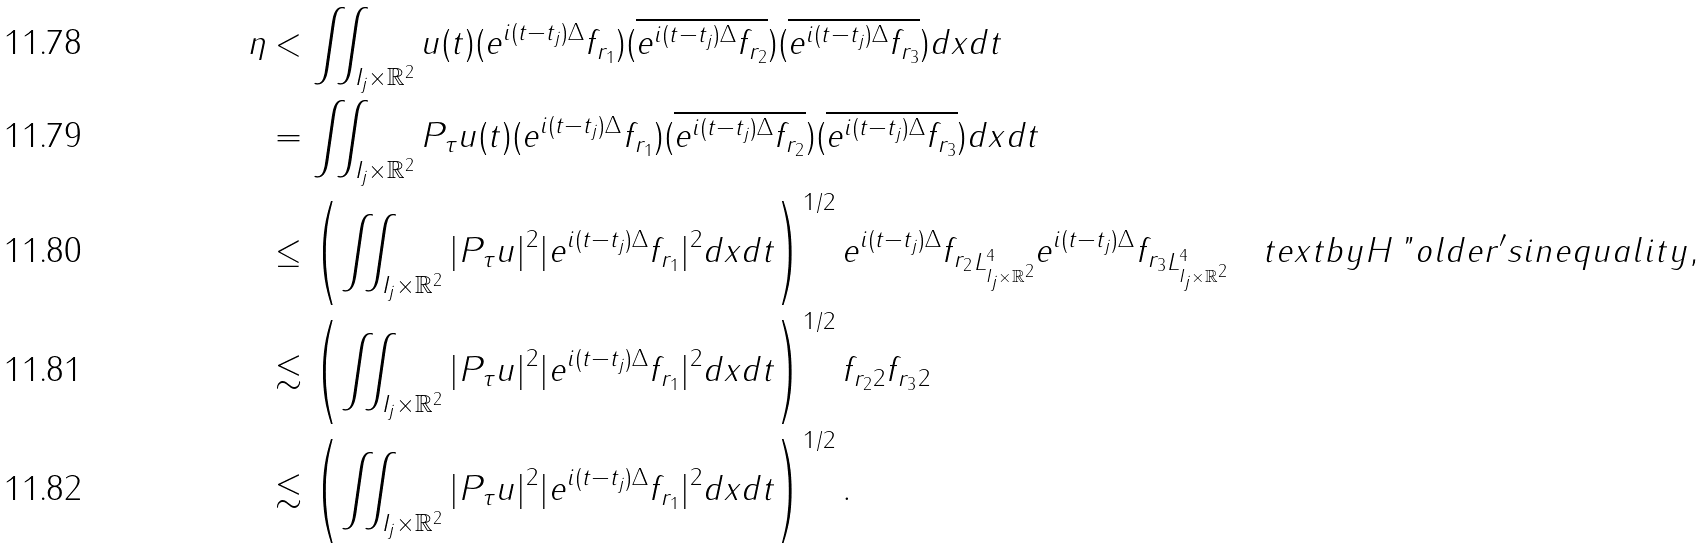<formula> <loc_0><loc_0><loc_500><loc_500>\eta & < \iint _ { I _ { j } \times \mathbb { R } ^ { 2 } } u ( t ) ( e ^ { i ( t - t _ { j } ) \Delta } f _ { r _ { 1 } } ) ( \overline { e ^ { i ( t - t _ { j } ) \Delta } f _ { r _ { 2 } } } ) ( \overline { e ^ { i ( t - t _ { j } ) \Delta } f _ { r _ { 3 } } } ) d x d t \\ & = \iint _ { I _ { j } \times \mathbb { R } ^ { 2 } } P _ { \tau } u ( t ) ( e ^ { i ( t - t _ { j } ) \Delta } f _ { r _ { 1 } } ) ( \overline { e ^ { i ( t - t _ { j } ) \Delta } f _ { r _ { 2 } } } ) ( \overline { e ^ { i ( t - t _ { j } ) \Delta } f _ { r _ { 3 } } } ) d x d t \\ & \leq \left ( \iint _ { I _ { j } \times \mathbb { R } ^ { 2 } } | P _ { \tau } u | ^ { 2 } | e ^ { i ( t - t _ { j } ) \Delta } f _ { r _ { 1 } } | ^ { 2 } d x d t \right ) ^ { 1 / 2 } \| e ^ { i ( t - t _ { j } ) \Delta } f _ { r _ { 2 } } \| _ { L ^ { 4 } _ { I _ { j } \times \mathbb { R } ^ { 2 } } } \| e ^ { i ( t - t _ { j } ) \Delta } f _ { r _ { 3 } } \| _ { L ^ { 4 } _ { I _ { j } \times \mathbb { R } ^ { 2 } } } \quad t e x t { b y H \ " { o } l d e r ^ { \prime } s i n e q u a l i t y , } \\ & \lesssim \left ( \iint _ { I _ { j } \times \mathbb { R } ^ { 2 } } | P _ { \tau } u | ^ { 2 } | e ^ { i ( t - t _ { j } ) \Delta } f _ { r _ { 1 } } | ^ { 2 } d x d t \right ) ^ { 1 / 2 } \| f _ { r _ { 2 } } \| _ { 2 } \| f _ { r _ { 3 } } \| _ { 2 } \\ & \lesssim \left ( \iint _ { I _ { j } \times \mathbb { R } ^ { 2 } } | P _ { \tau } u | ^ { 2 } | e ^ { i ( t - t _ { j } ) \Delta } f _ { r _ { 1 } } | ^ { 2 } d x d t \right ) ^ { 1 / 2 } .</formula> 